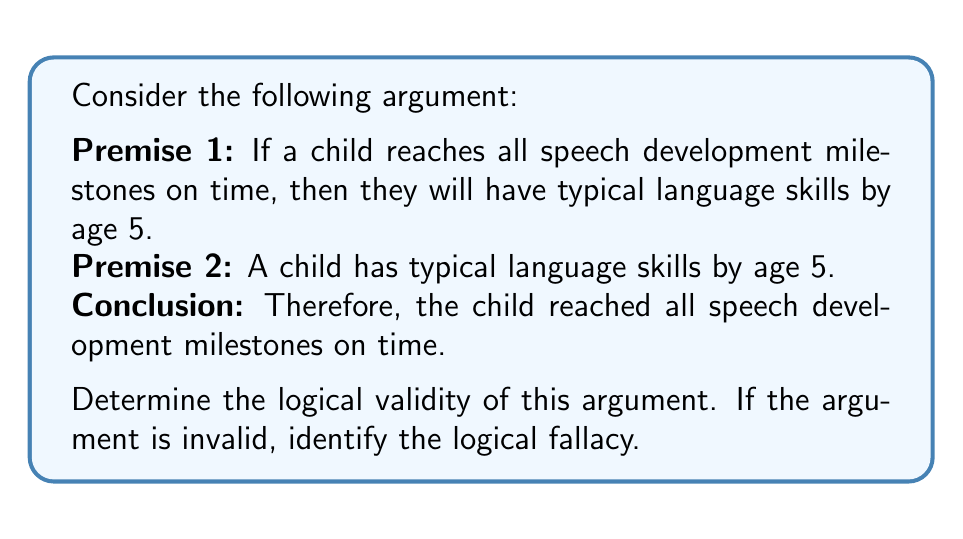Could you help me with this problem? To determine the logical validity of this argument, we need to examine its structure and see if the conclusion necessarily follows from the premises. Let's break it down using symbolic logic:

Let:
P: A child reaches all speech development milestones on time
Q: A child has typical language skills by age 5

The argument can be represented as:

Premise 1: $P \rightarrow Q$ (If P, then Q)
Premise 2: $Q$
Conclusion: $\therefore P$

This argument structure is known as the fallacy of affirming the consequent. It takes the form:

$$
\begin{align}
P &\rightarrow Q \\
&Q \\
\therefore &P
\end{align}
$$

This form is not logically valid because it doesn't necessarily follow that P is true just because Q is true. There could be other reasons for Q to be true that are not related to P.

In the context of speech development:
- There could be other factors contributing to typical language skills by age 5, not just reaching all milestones on time.
- Some children might have atypical milestone progression but still achieve typical language skills by age 5 through other means (e.g., intensive therapy, compensatory strategies).

To make this a valid argument, we would need to have the premise "Q → P" (If a child has typical language skills by age 5, then they reached all speech development milestones on time), which is not given and is not necessarily true in all cases.

Therefore, this argument is invalid due to the fallacy of affirming the consequent.
Answer: The argument is invalid. It commits the fallacy of affirming the consequent. 